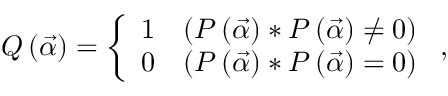Convert formula to latex. <formula><loc_0><loc_0><loc_500><loc_500>Q \left ( \vec { \alpha } \right ) = \left \{ \begin{array} { l l } { 1 } & { \left ( P \left ( \vec { \alpha } \right ) \ast P \left ( \vec { \alpha } \right ) \neq 0 \right ) } \\ { 0 } & { ( P \left ( \vec { \alpha } \right ) \ast P \left ( \vec { \alpha } \right ) = 0 ) } \end{array} ,</formula> 